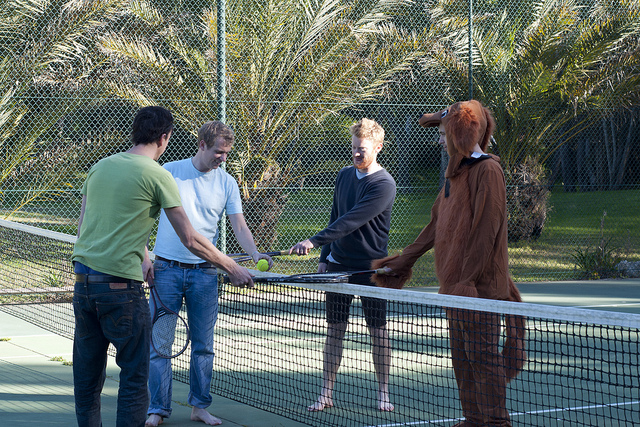Please provide the bounding box coordinate of the region this sentence describes: a man in a white shirt holding a tennis ball. [0.22, 0.36, 0.42, 0.83] 